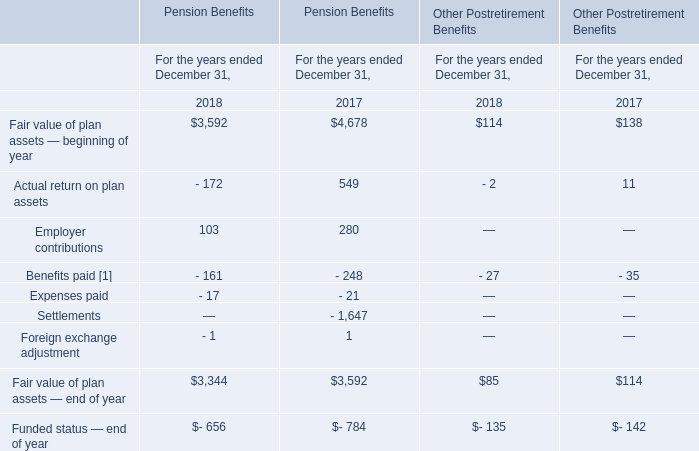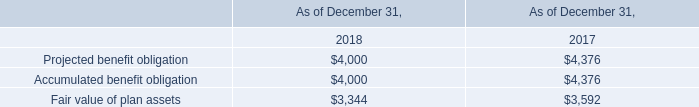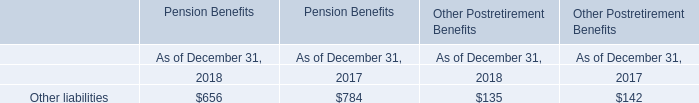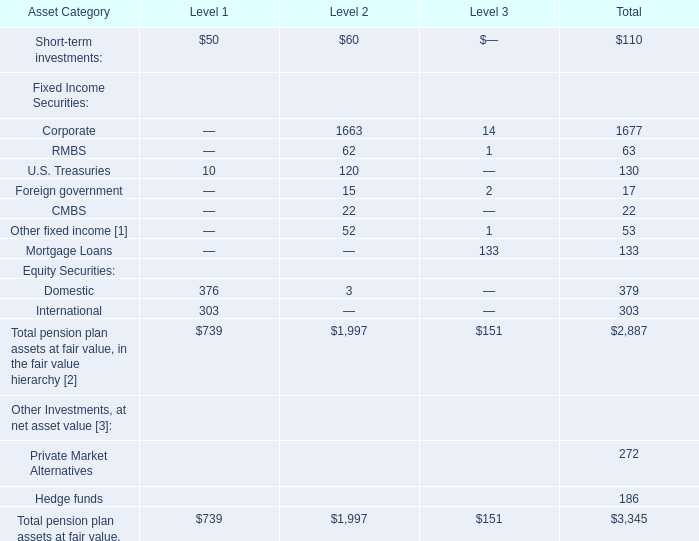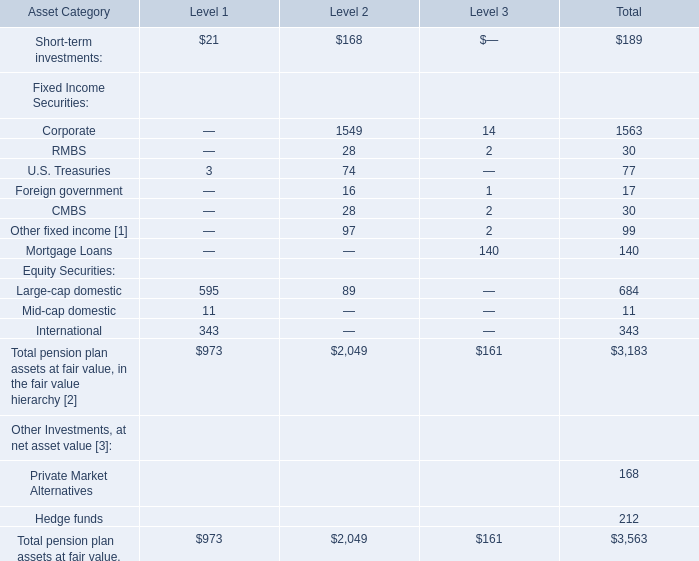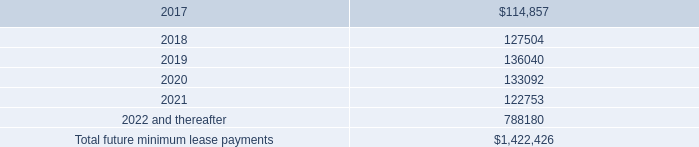In which Level is Total pension plan assets at fair value. the least? 
Answer: 3. 